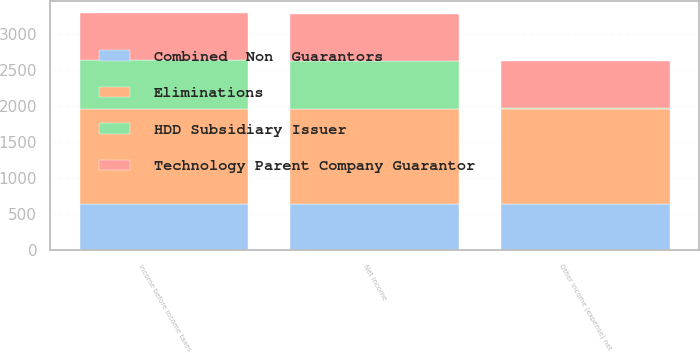Convert chart. <chart><loc_0><loc_0><loc_500><loc_500><stacked_bar_chart><ecel><fcel>Other income (expense) net<fcel>Income before income taxes<fcel>Net income<nl><fcel>Combined  Non  Guarantors<fcel>642<fcel>641<fcel>641<nl><fcel>Technology Parent Company Guarantor<fcel>654<fcel>651<fcel>651<nl><fcel>HDD Subsidiary Issuer<fcel>12<fcel>683<fcel>664<nl><fcel>Eliminations<fcel>1315<fcel>1315<fcel>1315<nl></chart> 